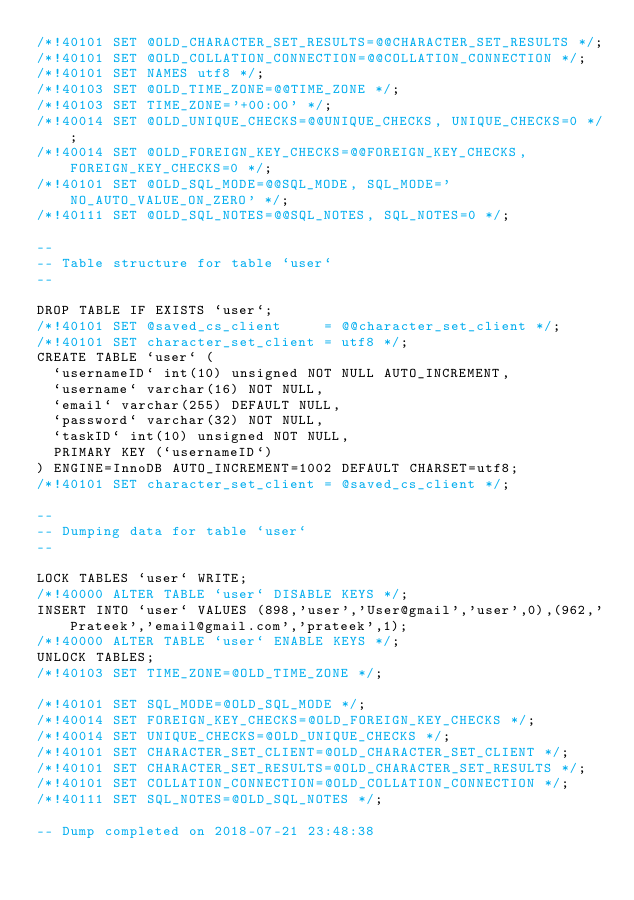Convert code to text. <code><loc_0><loc_0><loc_500><loc_500><_SQL_>/*!40101 SET @OLD_CHARACTER_SET_RESULTS=@@CHARACTER_SET_RESULTS */;
/*!40101 SET @OLD_COLLATION_CONNECTION=@@COLLATION_CONNECTION */;
/*!40101 SET NAMES utf8 */;
/*!40103 SET @OLD_TIME_ZONE=@@TIME_ZONE */;
/*!40103 SET TIME_ZONE='+00:00' */;
/*!40014 SET @OLD_UNIQUE_CHECKS=@@UNIQUE_CHECKS, UNIQUE_CHECKS=0 */;
/*!40014 SET @OLD_FOREIGN_KEY_CHECKS=@@FOREIGN_KEY_CHECKS, FOREIGN_KEY_CHECKS=0 */;
/*!40101 SET @OLD_SQL_MODE=@@SQL_MODE, SQL_MODE='NO_AUTO_VALUE_ON_ZERO' */;
/*!40111 SET @OLD_SQL_NOTES=@@SQL_NOTES, SQL_NOTES=0 */;

--
-- Table structure for table `user`
--

DROP TABLE IF EXISTS `user`;
/*!40101 SET @saved_cs_client     = @@character_set_client */;
/*!40101 SET character_set_client = utf8 */;
CREATE TABLE `user` (
  `usernameID` int(10) unsigned NOT NULL AUTO_INCREMENT,
  `username` varchar(16) NOT NULL,
  `email` varchar(255) DEFAULT NULL,
  `password` varchar(32) NOT NULL,
  `taskID` int(10) unsigned NOT NULL,
  PRIMARY KEY (`usernameID`)
) ENGINE=InnoDB AUTO_INCREMENT=1002 DEFAULT CHARSET=utf8;
/*!40101 SET character_set_client = @saved_cs_client */;

--
-- Dumping data for table `user`
--

LOCK TABLES `user` WRITE;
/*!40000 ALTER TABLE `user` DISABLE KEYS */;
INSERT INTO `user` VALUES (898,'user','User@gmail','user',0),(962,'Prateek','email@gmail.com','prateek',1);
/*!40000 ALTER TABLE `user` ENABLE KEYS */;
UNLOCK TABLES;
/*!40103 SET TIME_ZONE=@OLD_TIME_ZONE */;

/*!40101 SET SQL_MODE=@OLD_SQL_MODE */;
/*!40014 SET FOREIGN_KEY_CHECKS=@OLD_FOREIGN_KEY_CHECKS */;
/*!40014 SET UNIQUE_CHECKS=@OLD_UNIQUE_CHECKS */;
/*!40101 SET CHARACTER_SET_CLIENT=@OLD_CHARACTER_SET_CLIENT */;
/*!40101 SET CHARACTER_SET_RESULTS=@OLD_CHARACTER_SET_RESULTS */;
/*!40101 SET COLLATION_CONNECTION=@OLD_COLLATION_CONNECTION */;
/*!40111 SET SQL_NOTES=@OLD_SQL_NOTES */;

-- Dump completed on 2018-07-21 23:48:38
</code> 